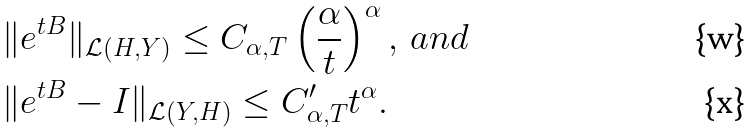<formula> <loc_0><loc_0><loc_500><loc_500>& \| e ^ { t B } \| _ { \mathcal { L } ( H , Y ) } \leq C _ { \alpha , T } \left ( \frac { \alpha } { t } \right ) ^ { \alpha } , \, a n d \\ & \| e ^ { t B } - I \| _ { \mathcal { L } ( Y , H ) } \leq C ^ { \prime } _ { \alpha , T } t ^ { \alpha } .</formula> 